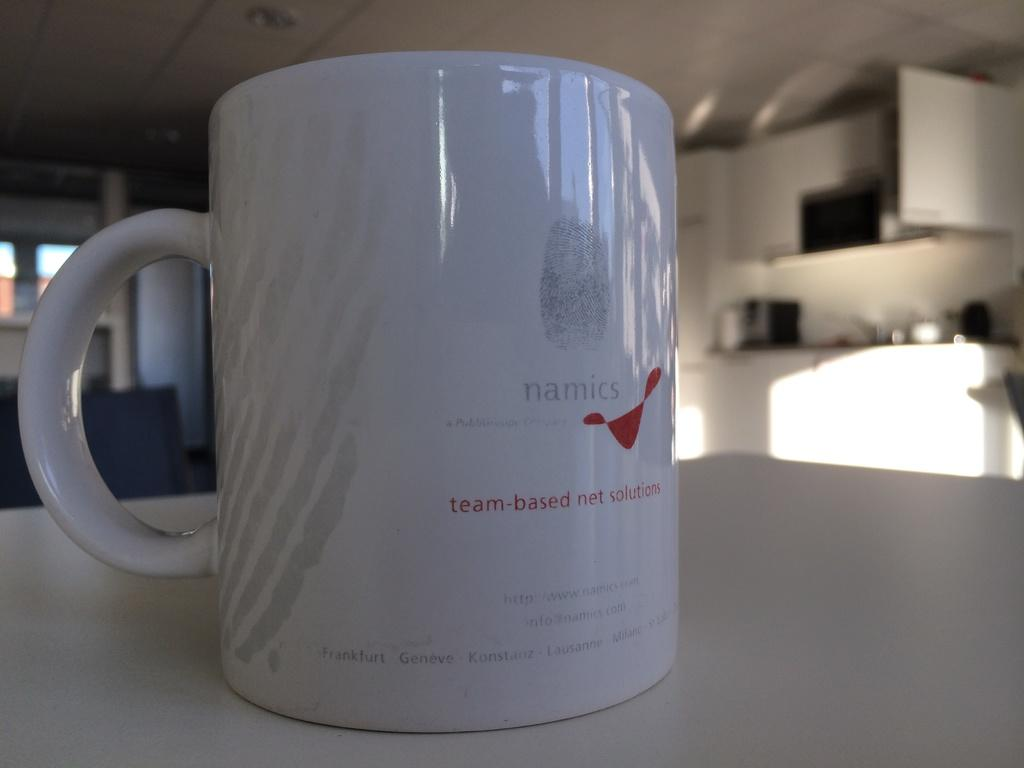<image>
Describe the image concisely. Namics provides team-based net solutions to their clients. 